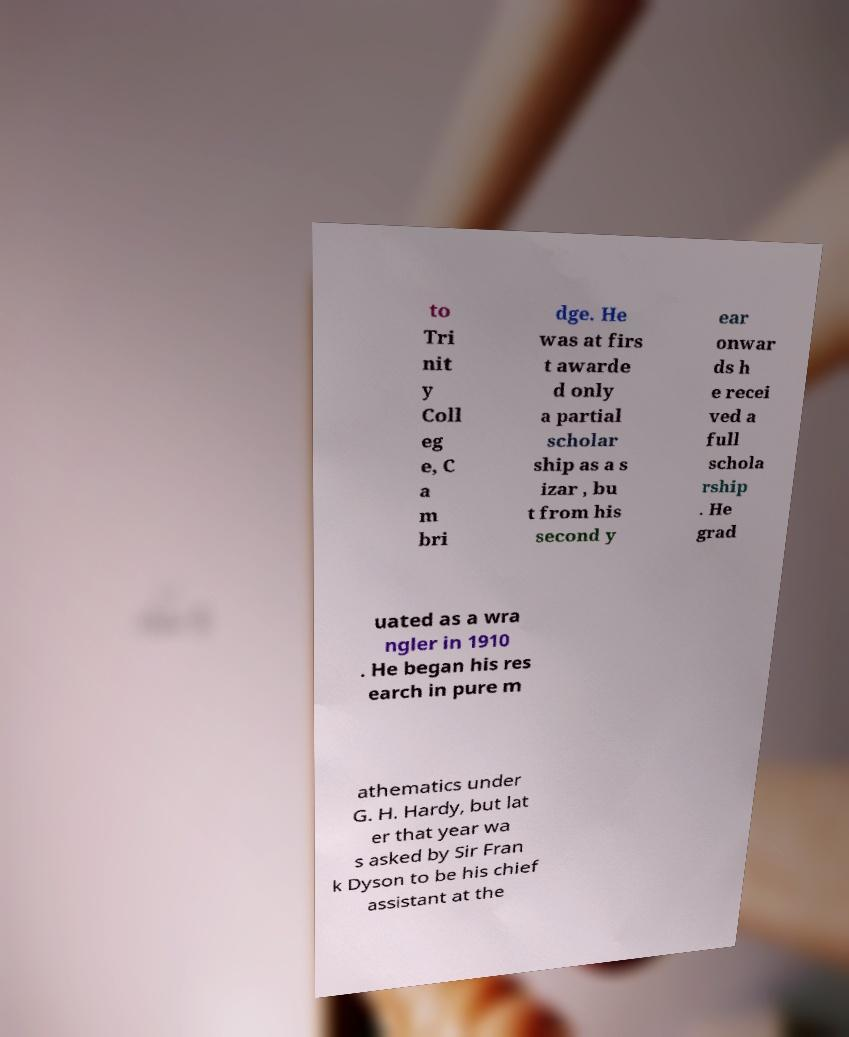Please identify and transcribe the text found in this image. to Tri nit y Coll eg e, C a m bri dge. He was at firs t awarde d only a partial scholar ship as a s izar , bu t from his second y ear onwar ds h e recei ved a full schola rship . He grad uated as a wra ngler in 1910 . He began his res earch in pure m athematics under G. H. Hardy, but lat er that year wa s asked by Sir Fran k Dyson to be his chief assistant at the 